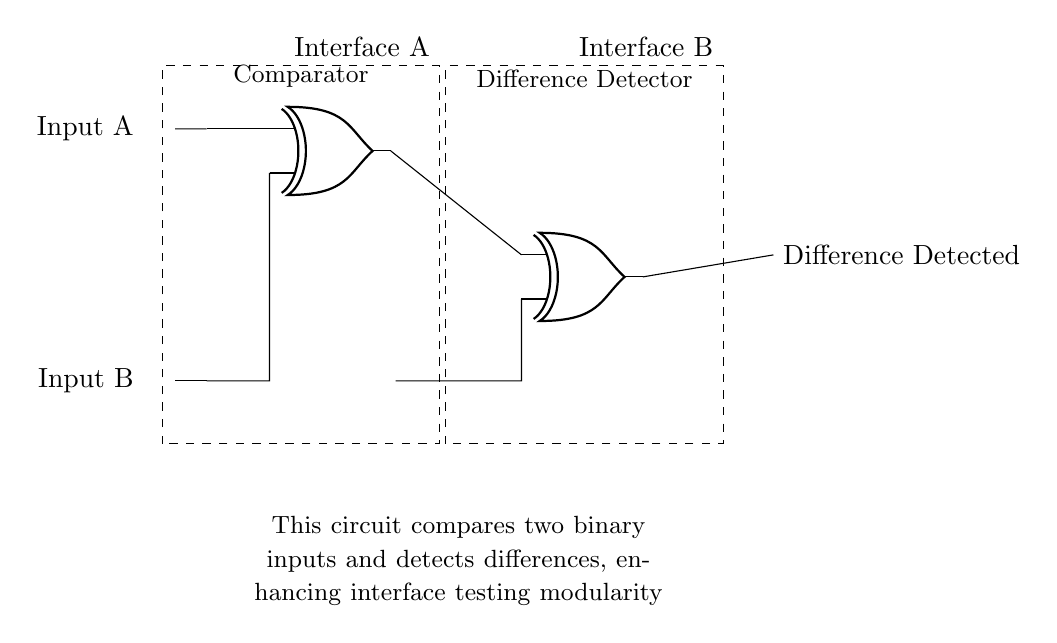What are the inputs to the comparator circuit? The inputs are labeled as Input A and Input B, which are both binary inputs provided from the left side of the circuit.
Answer: Input A, Input B What is the output of the circuit? The output is labeled as "Difference Detected," indicating that the circuit detects a difference between the two inputs.
Answer: Difference Detected How many XOR gates are used in this circuit? There are two XOR gates shown in the circuit, with the first XOR gate taking input from Input A and Input B, and the second XOR gate taking output from the first gate and an additional line from Input B.
Answer: Two What is the purpose of this circuit? The purpose of the circuit is to compare two binary inputs to check for differences, which enhances modularity in interface testing as stated in the explanatory text.
Answer: To detect differences Explain how the first XOR gate works in this circuit. The first XOR gate takes two inputs: Input A and Input B. It outputs a high signal (1) if the inputs are different (one is high and the other is low), and outputs a low signal (0) if the inputs are the same.
Answer: It outputs 1 if different What does the dashed rectangle represent in this circuit? The dashed rectangles represent Interface A and Interface B, indicating modular sections of the circuit which separate inputs and outputs, enhancing maintainability by organizing the circuit's structure.
Answer: Interface A, Interface B What is the significance of using XOR gates in this comparator circuit? XOR gates are significant because they provide the functionality to detect differences between two binary inputs effectively; they only output high when the inputs differ, thus they are ideal for comparison tasks in logic circuits.
Answer: To detect differences 